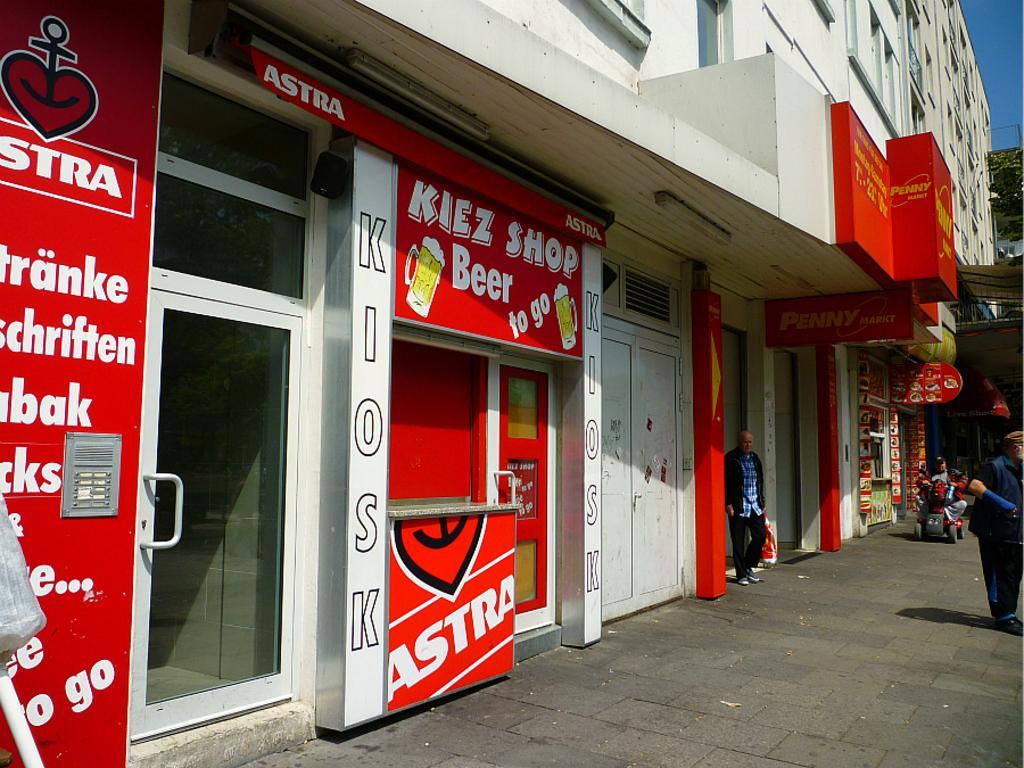Describe this image in one or two sentences. In this image we can see there are buildings and stalls, in front of the building there are two persons standing and another person sat in the vehicle. 